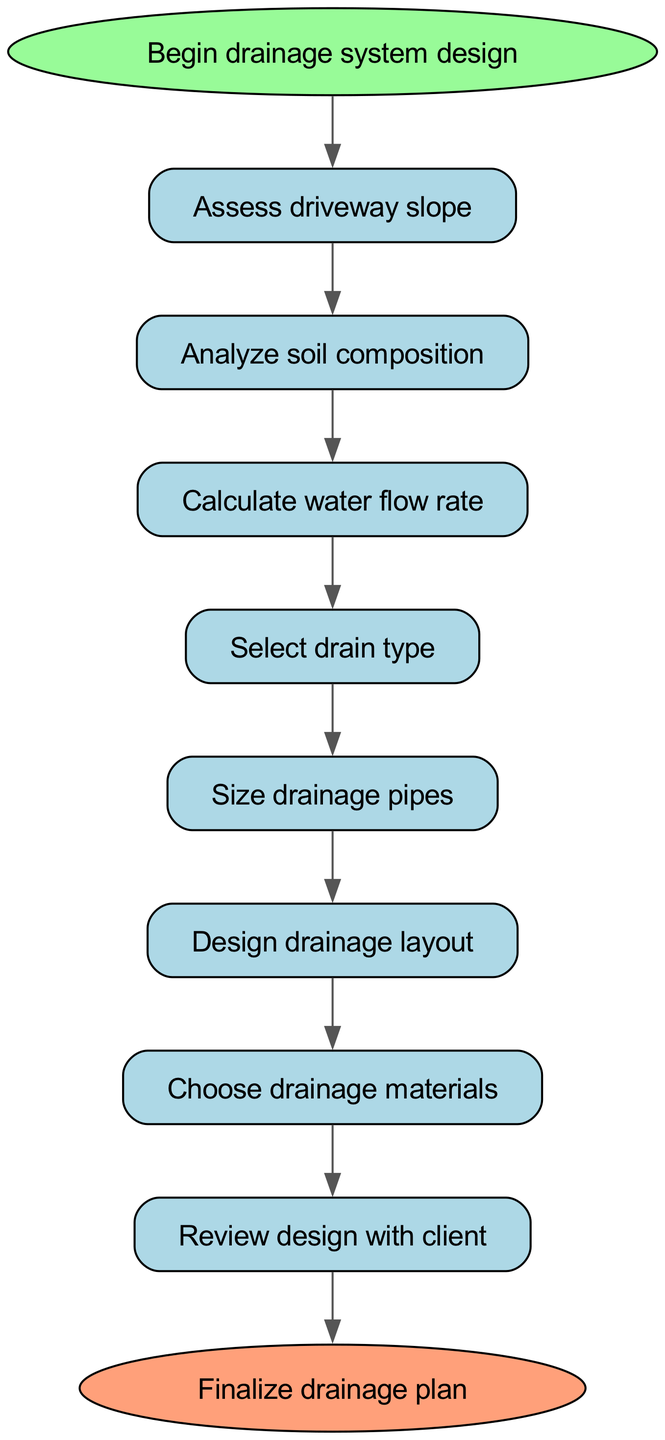What is the first step in the drainage system design process? The diagram indicates that the first step is labeled "Begin drainage system design," which has a clear identifier in the diagram as the starting point.
Answer: Begin drainage system design How many nodes are present in the diagram? By counting all the distinct steps and terminators in the diagram, we find a total of ten nodes, including the start and end nodes.
Answer: Ten What is the last step before finalizing the drainage plan? The diagram shows that after reviewing the design with the client, the process proceeds to finalize the drainage plan, indicating it as the last step in the sequence.
Answer: Review design with client Which step follows the calculation of water flow rate? The flowchart demonstrates that after the calculation of the water flow rate, the next step is to select the drain type, as indicated by the directed edge connecting these two nodes.
Answer: Select drain type From which node does the drainage materials selection process begin? Examining the edges, it is clear that the selection of drainage materials begins after the design drainage layout step, as there is a direct connection from layout design to materials.
Answer: Design drainage layout How many edges are there in the diagram? The flowchart contains numerous connections that guide the flow from one step to the next; counting these connections reveals a total of nine edges.
Answer: Nine What type of node is the "end" node? The diagram categorizes the "end" node distinctly, as it is shaped like an oval, differentiating it from other nodes, which are rectangular, representing the completion of the process.
Answer: Oval What is the purpose of the soil analysis step? The soil analysis step in the flowchart is aimed at analyzing soil composition, which is crucial for determining effective drainage solutions, as reflected in the labeling of that step.
Answer: Analyze soil composition Which step leads directly to sizing the drainage pipes? Following the diagram's flow, it is evident that the step leading to sizing the drainage pipes is the selection of the drain type, establishing a sequential connection that requires completion before moving forward.
Answer: Select drain type 